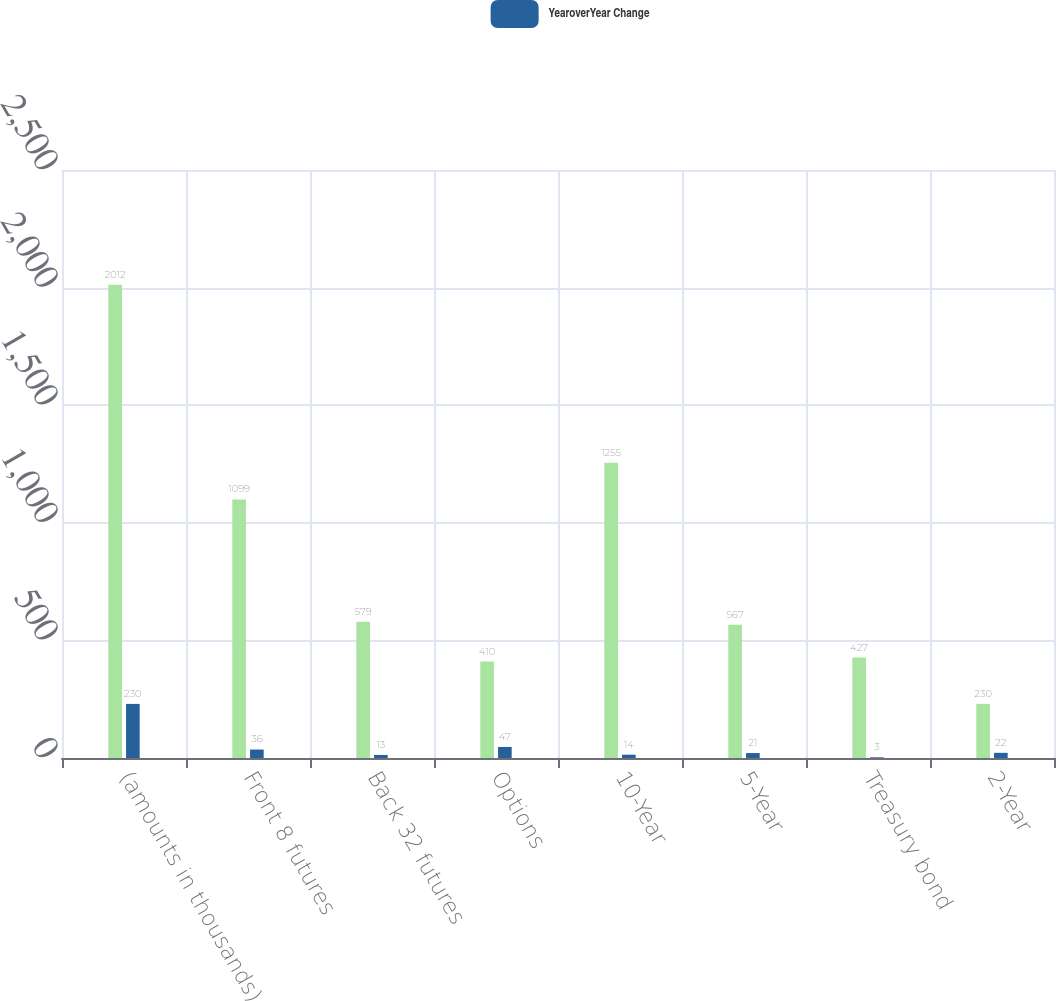Convert chart to OTSL. <chart><loc_0><loc_0><loc_500><loc_500><stacked_bar_chart><ecel><fcel>(amounts in thousands)<fcel>Front 8 futures<fcel>Back 32 futures<fcel>Options<fcel>10-Year<fcel>5-Year<fcel>Treasury bond<fcel>2-Year<nl><fcel>nan<fcel>2012<fcel>1099<fcel>579<fcel>410<fcel>1255<fcel>567<fcel>427<fcel>230<nl><fcel>YearoverYear Change<fcel>230<fcel>36<fcel>13<fcel>47<fcel>14<fcel>21<fcel>3<fcel>22<nl></chart> 